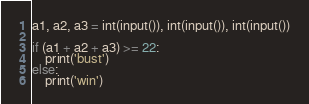<code> <loc_0><loc_0><loc_500><loc_500><_Python_>a1, a2, a3 = int(input()), int(input()), int(input())

if (a1 + a2 + a3) >= 22:
    print('bust')
else:
    print('win')
</code> 